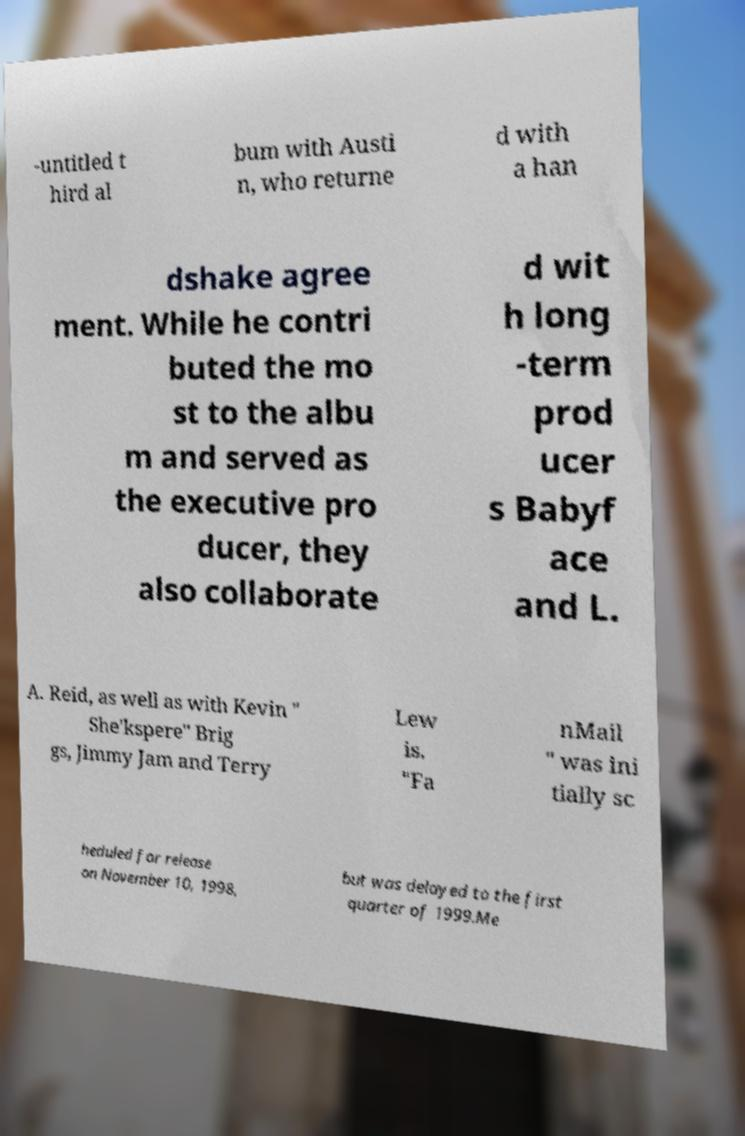For documentation purposes, I need the text within this image transcribed. Could you provide that? -untitled t hird al bum with Austi n, who returne d with a han dshake agree ment. While he contri buted the mo st to the albu m and served as the executive pro ducer, they also collaborate d wit h long -term prod ucer s Babyf ace and L. A. Reid, as well as with Kevin " She'kspere" Brig gs, Jimmy Jam and Terry Lew is. "Fa nMail " was ini tially sc heduled for release on November 10, 1998, but was delayed to the first quarter of 1999.Me 